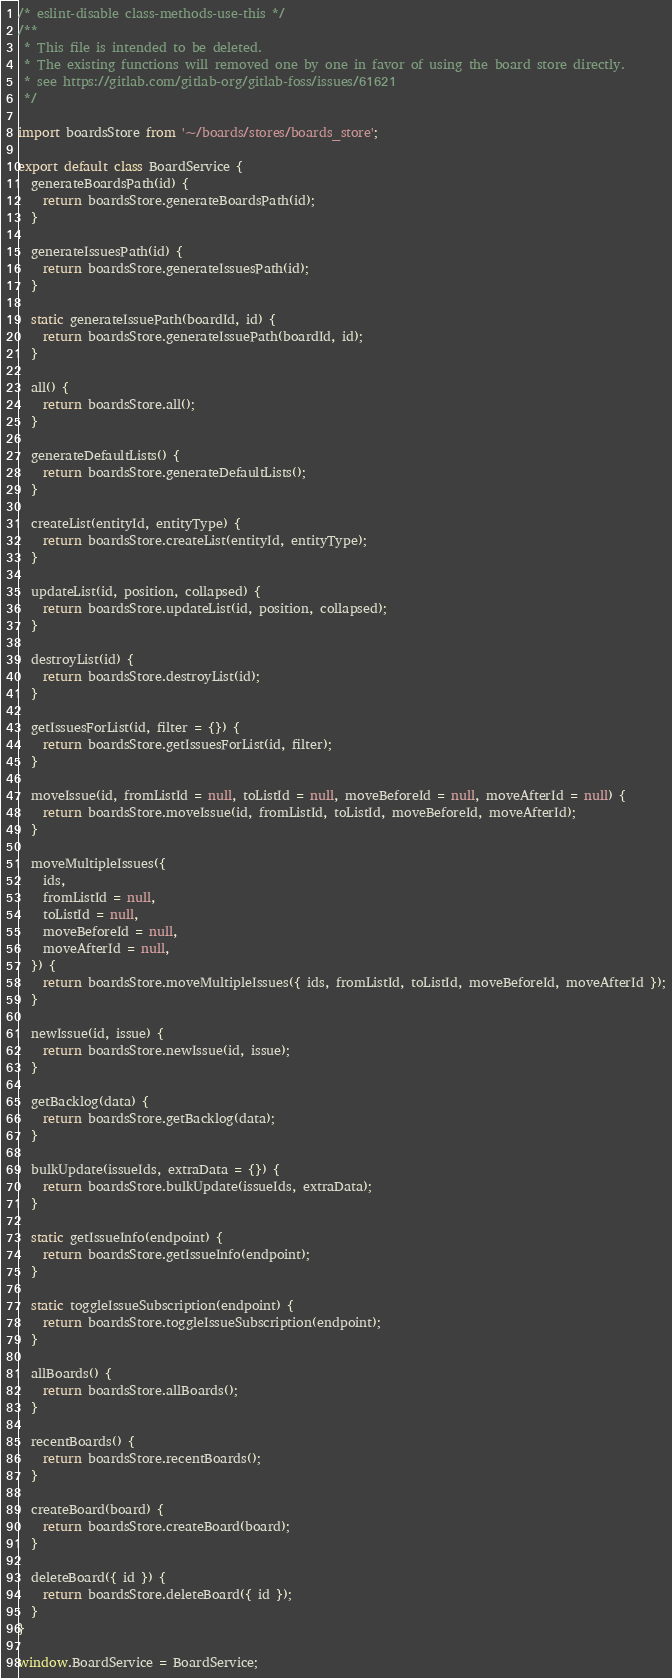<code> <loc_0><loc_0><loc_500><loc_500><_JavaScript_>/* eslint-disable class-methods-use-this */
/**
 * This file is intended to be deleted.
 * The existing functions will removed one by one in favor of using the board store directly.
 * see https://gitlab.com/gitlab-org/gitlab-foss/issues/61621
 */

import boardsStore from '~/boards/stores/boards_store';

export default class BoardService {
  generateBoardsPath(id) {
    return boardsStore.generateBoardsPath(id);
  }

  generateIssuesPath(id) {
    return boardsStore.generateIssuesPath(id);
  }

  static generateIssuePath(boardId, id) {
    return boardsStore.generateIssuePath(boardId, id);
  }

  all() {
    return boardsStore.all();
  }

  generateDefaultLists() {
    return boardsStore.generateDefaultLists();
  }

  createList(entityId, entityType) {
    return boardsStore.createList(entityId, entityType);
  }

  updateList(id, position, collapsed) {
    return boardsStore.updateList(id, position, collapsed);
  }

  destroyList(id) {
    return boardsStore.destroyList(id);
  }

  getIssuesForList(id, filter = {}) {
    return boardsStore.getIssuesForList(id, filter);
  }

  moveIssue(id, fromListId = null, toListId = null, moveBeforeId = null, moveAfterId = null) {
    return boardsStore.moveIssue(id, fromListId, toListId, moveBeforeId, moveAfterId);
  }

  moveMultipleIssues({
    ids,
    fromListId = null,
    toListId = null,
    moveBeforeId = null,
    moveAfterId = null,
  }) {
    return boardsStore.moveMultipleIssues({ ids, fromListId, toListId, moveBeforeId, moveAfterId });
  }

  newIssue(id, issue) {
    return boardsStore.newIssue(id, issue);
  }

  getBacklog(data) {
    return boardsStore.getBacklog(data);
  }

  bulkUpdate(issueIds, extraData = {}) {
    return boardsStore.bulkUpdate(issueIds, extraData);
  }

  static getIssueInfo(endpoint) {
    return boardsStore.getIssueInfo(endpoint);
  }

  static toggleIssueSubscription(endpoint) {
    return boardsStore.toggleIssueSubscription(endpoint);
  }

  allBoards() {
    return boardsStore.allBoards();
  }

  recentBoards() {
    return boardsStore.recentBoards();
  }

  createBoard(board) {
    return boardsStore.createBoard(board);
  }

  deleteBoard({ id }) {
    return boardsStore.deleteBoard({ id });
  }
}

window.BoardService = BoardService;
</code> 